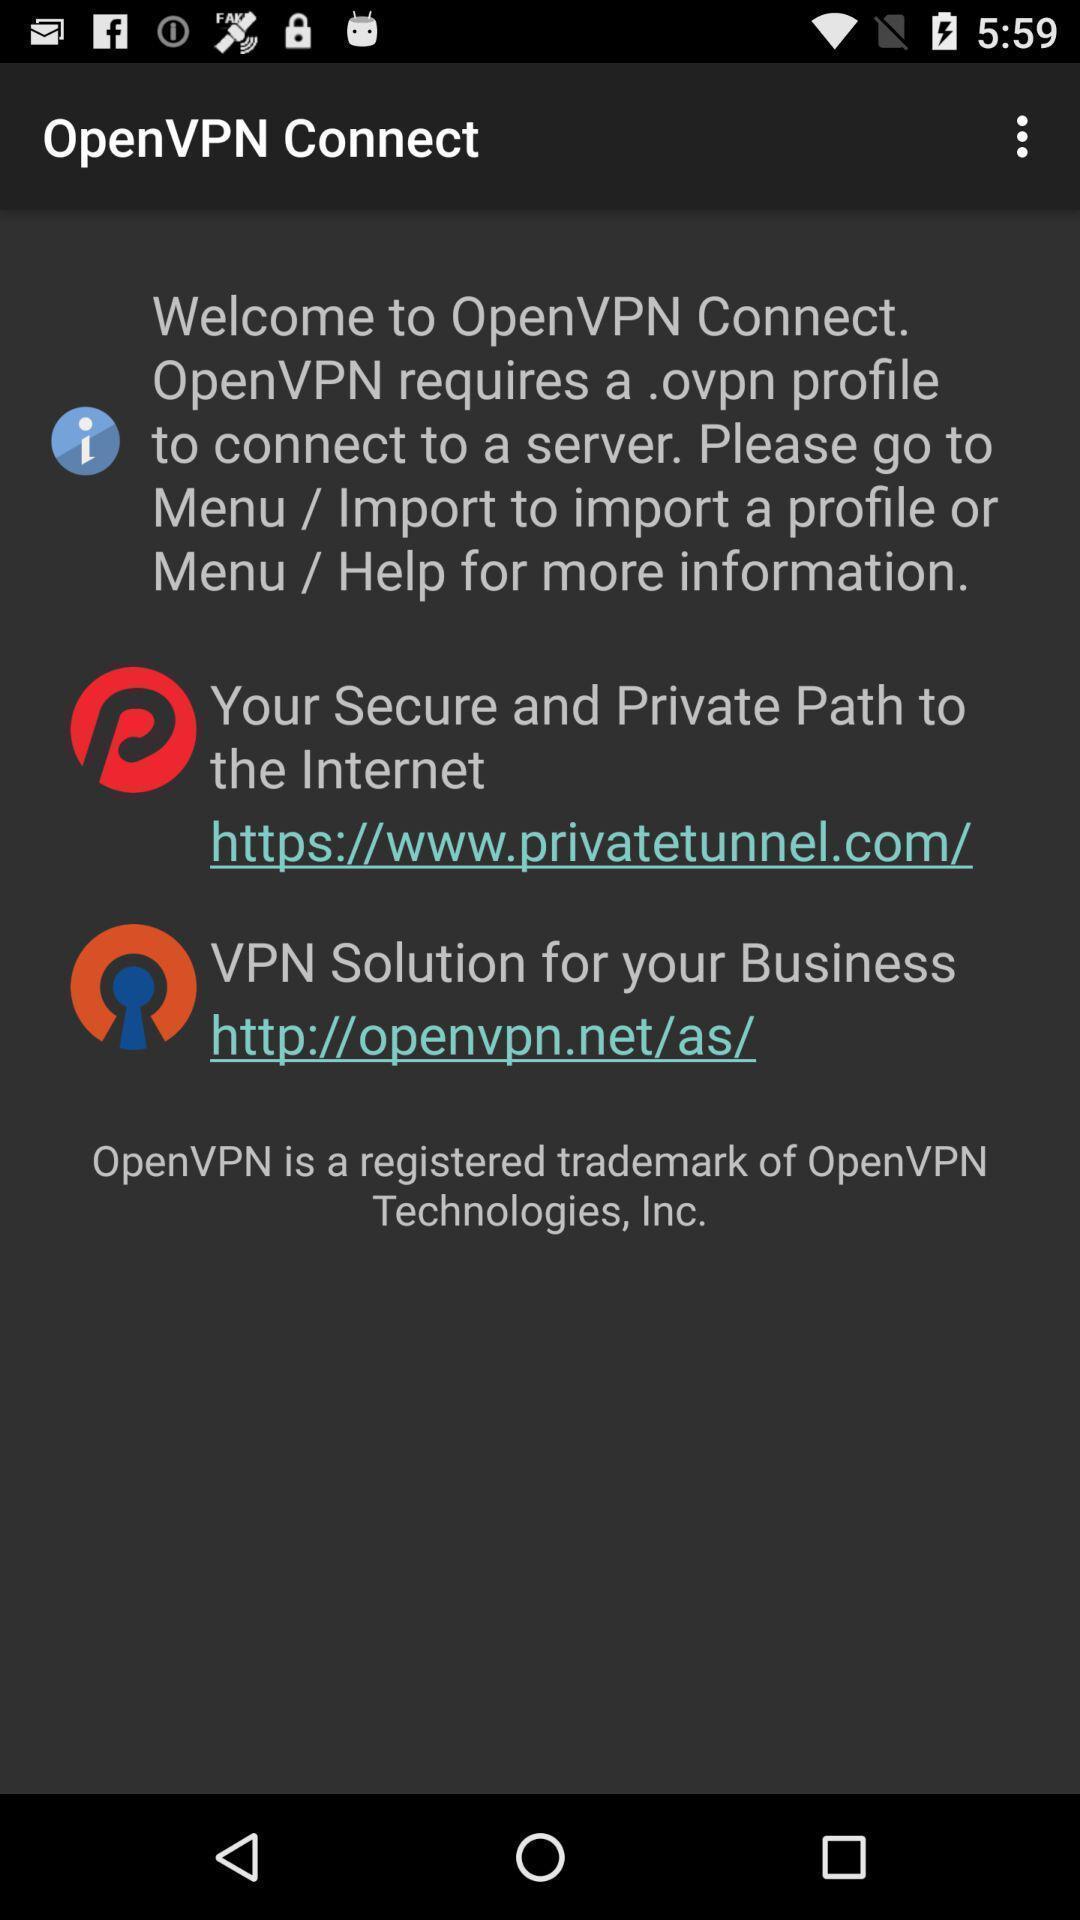Summarize the main components in this picture. Welcome page of the social app. 